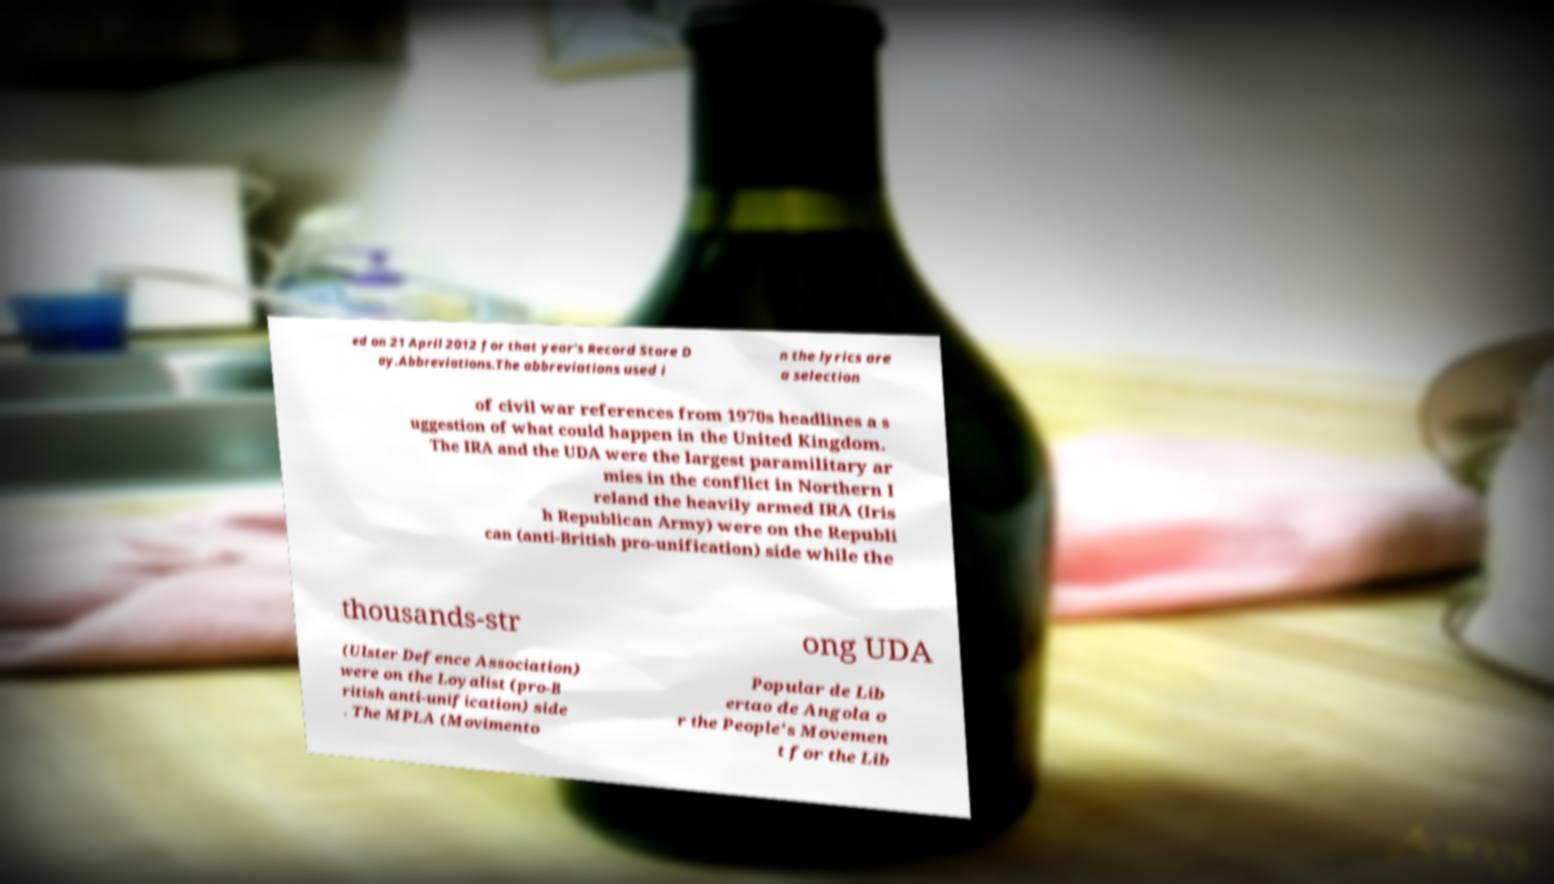For documentation purposes, I need the text within this image transcribed. Could you provide that? ed on 21 April 2012 for that year's Record Store D ay.Abbreviations.The abbreviations used i n the lyrics are a selection of civil war references from 1970s headlines a s uggestion of what could happen in the United Kingdom. The IRA and the UDA were the largest paramilitary ar mies in the conflict in Northern I reland the heavily armed IRA (Iris h Republican Army) were on the Republi can (anti-British pro-unification) side while the thousands-str ong UDA (Ulster Defence Association) were on the Loyalist (pro-B ritish anti-unification) side . The MPLA (Movimento Popular de Lib ertao de Angola o r the People's Movemen t for the Lib 